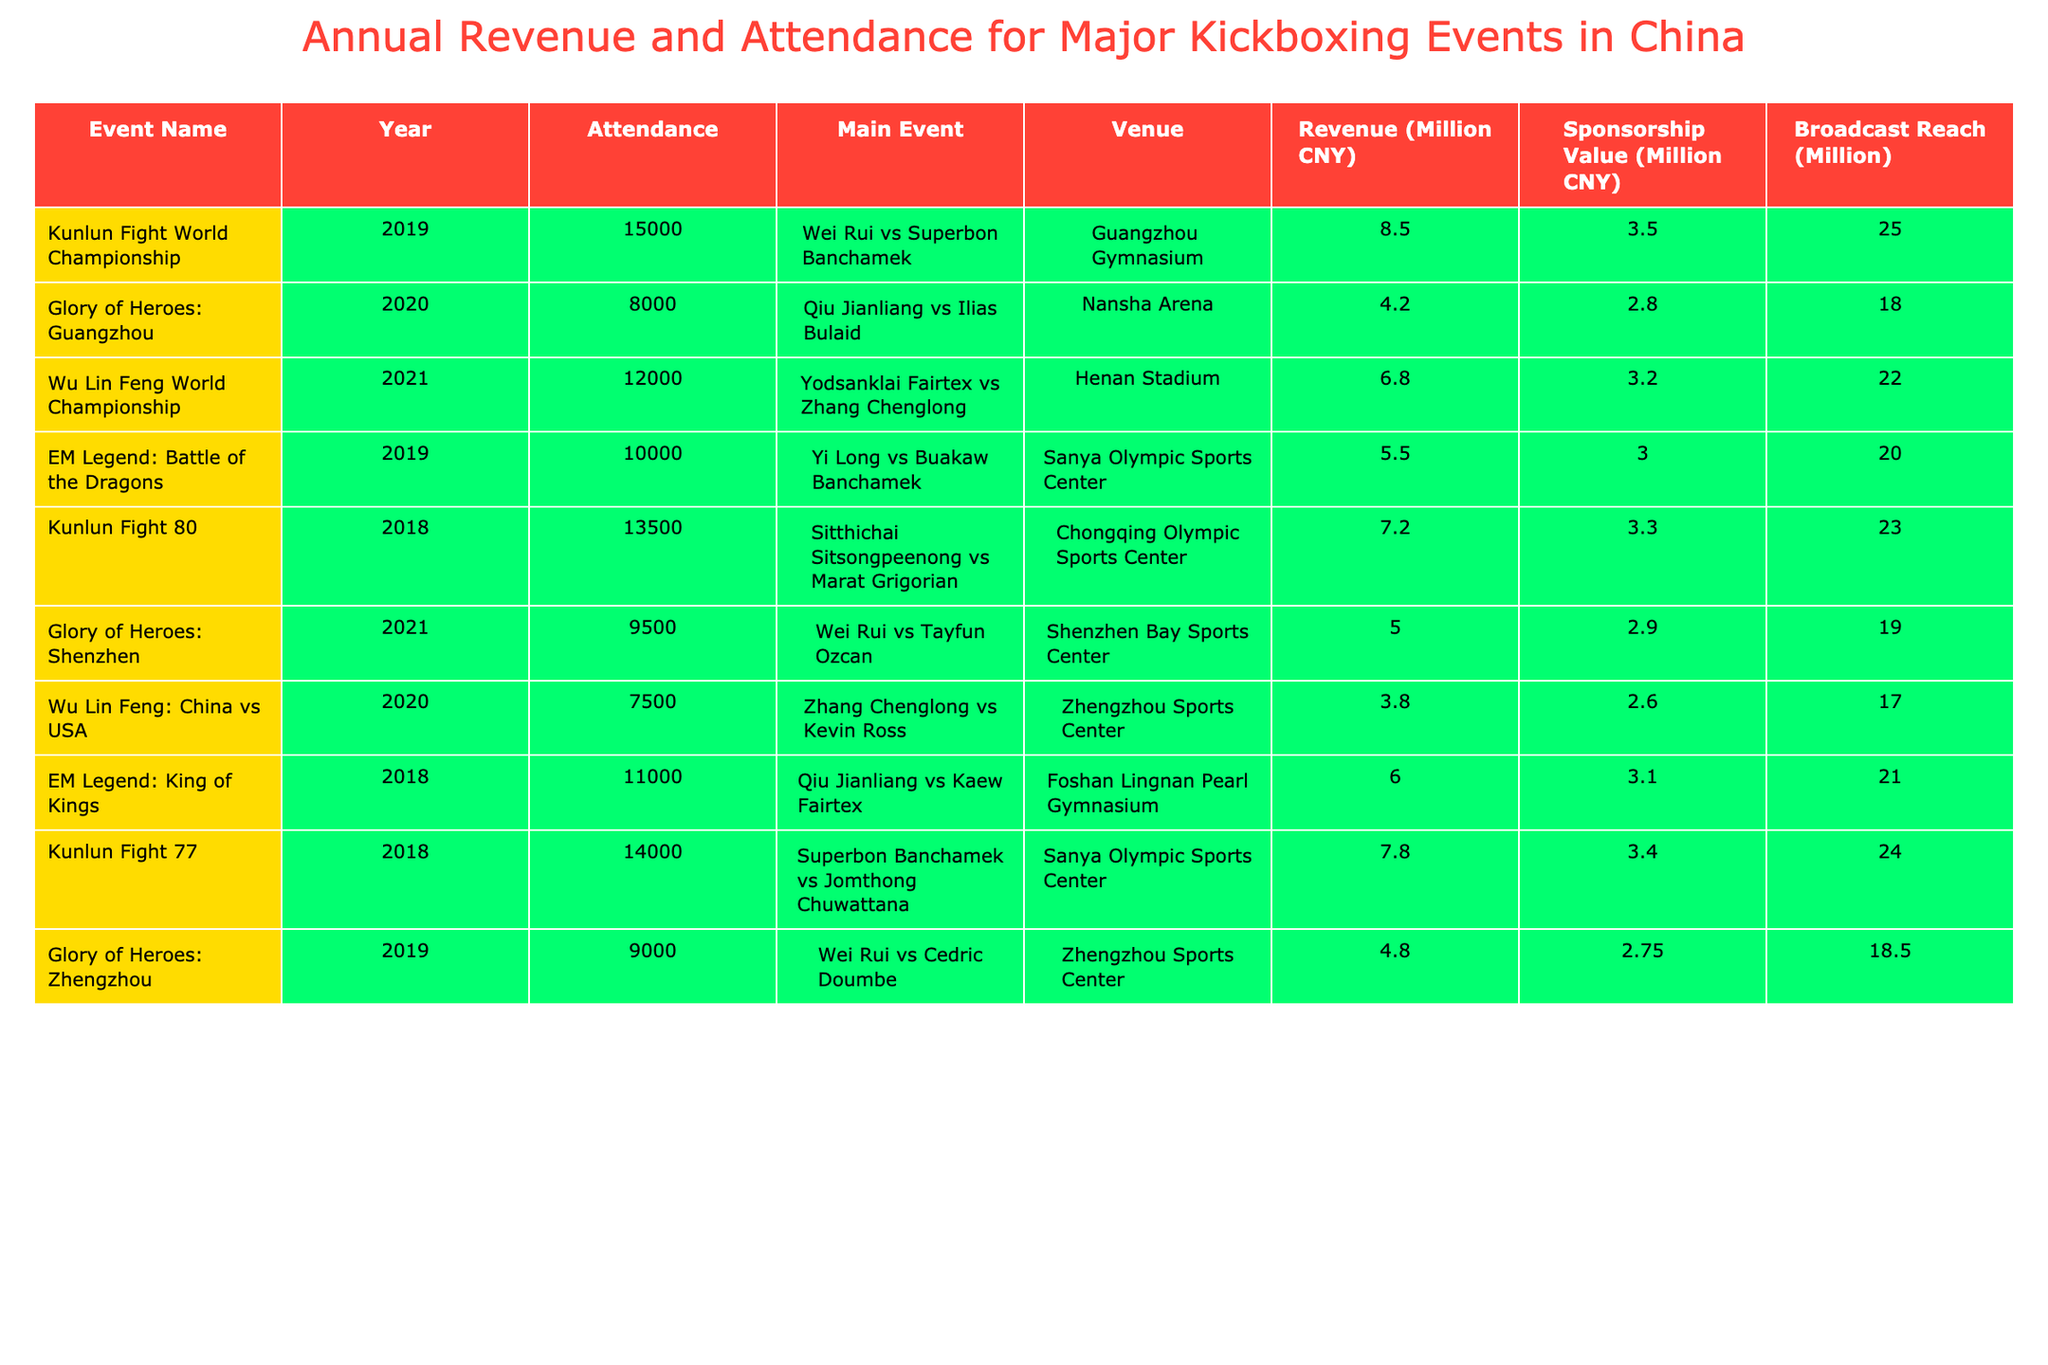What was the venue for the Kunlun Fight World Championship in 2019? The table lists the venue for the Kunlun Fight World Championship in 2019 as Guangzhou Gymnasium.
Answer: Guangzhou Gymnasium How much revenue did the EM Legend: Battle of the Dragons generate in 2019? The table shows that the revenue for the EM Legend: Battle of the Dragons in 2019 was 5,500,000 CNY.
Answer: 5,500,000 CNY What is the total attendance for the events listed in 2020? The 2020 attendance figures are 8,000 (Glory of Heroes: Guangzhou) and 7,500 (Wu Lin Feng: China vs USA), totaling 15,500 (8,000 + 7,500).
Answer: 15,500 Which event had the highest broadcast reach, and what was that reach? The event with the highest broadcast reach is "Kunlun Fight World Championship" in 2019 with a reach of 25,000,000.
Answer: 25,000,000 What is the average revenue generated by the events in 2018? The revenues for events in 2018 are 7,200,000 (Kunlun Fight 80), 6,000,000 (EM Legend: King of Kings), and 7,800,000 (Kunlun Fight 77). The average is (7,200,000 + 6,000,000 + 7,800,000) / 3 = 7,000,000 CNY.
Answer: 7,000,000 CNY Did any event in 2021 have a revenue below 5,000,000 CNY? The table shows that Glory of Heroes: Shenzhen in 2021 had a revenue of 5,000,000 CNY, so no events had revenue below this amount.
Answer: No What is the difference in attendance between the highest and lowest attended events? The highest attendance is 15,000 (Kunlun Fight World Championship, 2019) and the lowest is 7,500 (Wu Lin Feng: China vs USA, 2020). The difference is 15,000 - 7,500 = 7,500.
Answer: 7,500 Which year had the most events recorded in the table, and how many events were there? The table includes events from 2018, 2019, 2020, and 2021. All have two events except 2020, which has three events. Therefore, 2020 has the most events with three.
Answer: 2020, 3 events What is the total sponsorship value for all events held in 2019? The sponsorship values for 2019 events are 3,500,000 (Kunlun Fight World Championship) and 3,000,000 (EM Legend: Battle of the Dragons), totaling 6,500,000 CNY (3,500,000 + 3,000,000).
Answer: 6,500,000 CNY Among the events listed for 2021, which had the lowest sponsorship value, and what was that value? The lowest sponsorship value in 2021 is for Glory of Heroes: Shenzhen at 2,900,000 CNY.
Answer: 2,900,000 CNY 